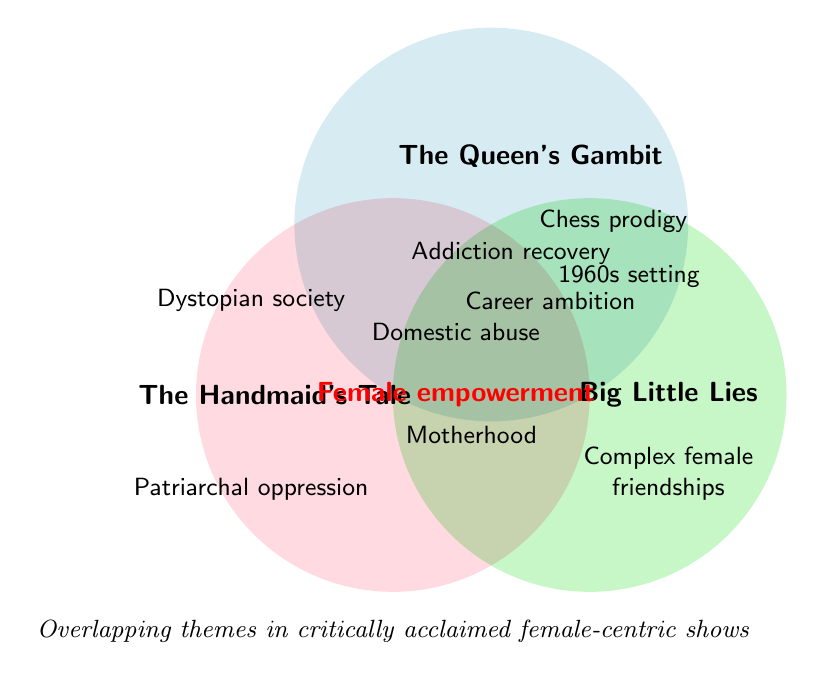What are the shows where domestic abuse is a theme? Look at the circles representing "The Handmaid's Tale" and "Big Little Lies". Both have the theme "Domestic abuse".
Answer: The Handmaid's Tale, Big Little Lies Which theme is present in all three shows? Find the theme that falls in the overlapping region of all three circles in the Venn Diagram. It's "Female empowerment".
Answer: Female empowerment What is a unique theme to "The Handmaid's Tale"? Locate the themes present only in "The Handmaid's Tale" circle without overlap. These are "Dystopian society" and "Patriarchal oppression".
Answer: Dystopian society, Patriarchal oppression Which show features a chess prodigy? Look at the circle representing "The Queen's Gambit". The theme "Chess prodigy" is located there.
Answer: The Queen's Gambit Compare the number of themes related to addiction recovery between "The Queen's Gambit" and "Big Little Lies". Identify the overlap for "Addiction recovery" in the respective circles for both shows. Both "The Queen's Gambit" and "Big Little Lies" feature this theme.
Answer: Both Does "Big Little Lies" and "The Handmaid's Tale" have any common themes other than "Female empowerment"? Check if there's another overlapping theme between "Big Little Lies" and "The Handmaid's Tale" aside from "Female empowerment". "Domestic abuse" and "Motherhood" are shared themes.
Answer: Yes, Domestic abuse, Motherhood For which show is "Complex female friendships" a theme? Locate the theme "Complex female friendships" in its specific circle. It falls within the "Big Little Lies" circle.
Answer: Big Little Lies Which show(s) highlight the theme of career ambition? Observe the circle regions where the theme "Career ambition" is present. It's present in both "The Queen's Gambit" and "Big Little Lies".
Answer: The Queen's Gambit, Big Little Lies What theme is found in "The Queen's Gambit" and "Big Little Lies" but not in "The Handmaid's Tale"? Locate the themes in the overlapping area of "The Queen's Gambit" and "Big Little Lies" and ensure they are not present in "The Handmaid's Tale". "Addiction recovery" and "Career ambition" fit this criterion.
Answer: Addiction recovery, Career ambition 